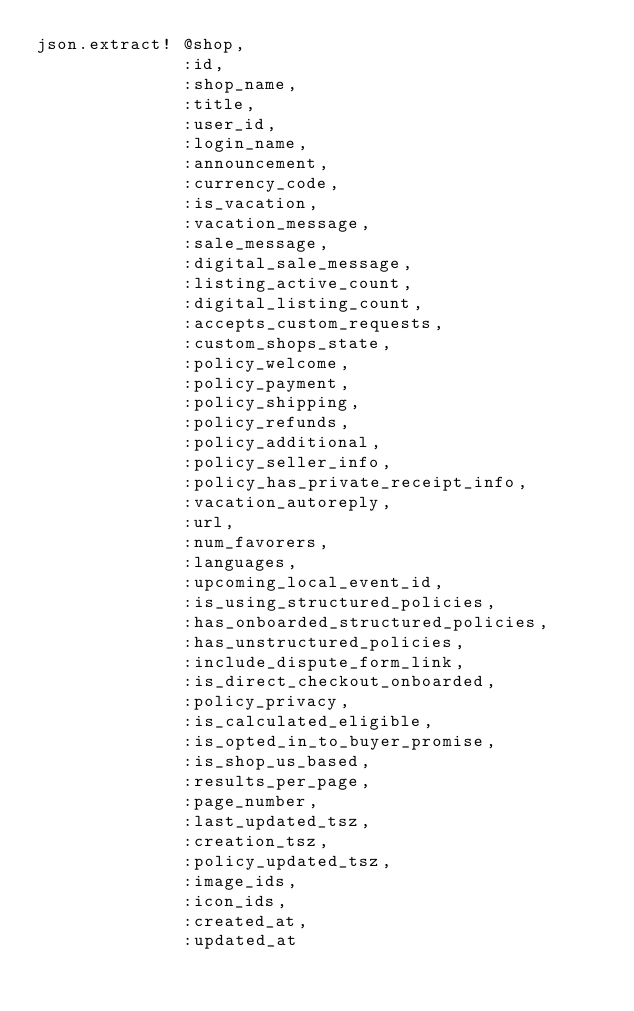<code> <loc_0><loc_0><loc_500><loc_500><_Ruby_>json.extract! @shop,
              :id,
              :shop_name,
              :title,
              :user_id,
              :login_name,
              :announcement,
              :currency_code,
              :is_vacation,
              :vacation_message,
              :sale_message,
              :digital_sale_message,
              :listing_active_count,
              :digital_listing_count,
              :accepts_custom_requests,
              :custom_shops_state,
              :policy_welcome,
              :policy_payment,
              :policy_shipping,
              :policy_refunds,
              :policy_additional,
              :policy_seller_info,
              :policy_has_private_receipt_info,
              :vacation_autoreply,
              :url,
              :num_favorers,
              :languages,
              :upcoming_local_event_id,
              :is_using_structured_policies,
              :has_onboarded_structured_policies,
              :has_unstructured_policies,
              :include_dispute_form_link,
              :is_direct_checkout_onboarded,
              :policy_privacy,
              :is_calculated_eligible,
              :is_opted_in_to_buyer_promise,
              :is_shop_us_based,
              :results_per_page,
              :page_number,
              :last_updated_tsz,
              :creation_tsz,
              :policy_updated_tsz,
              :image_ids,
              :icon_ids,
              :created_at,
              :updated_at
</code> 